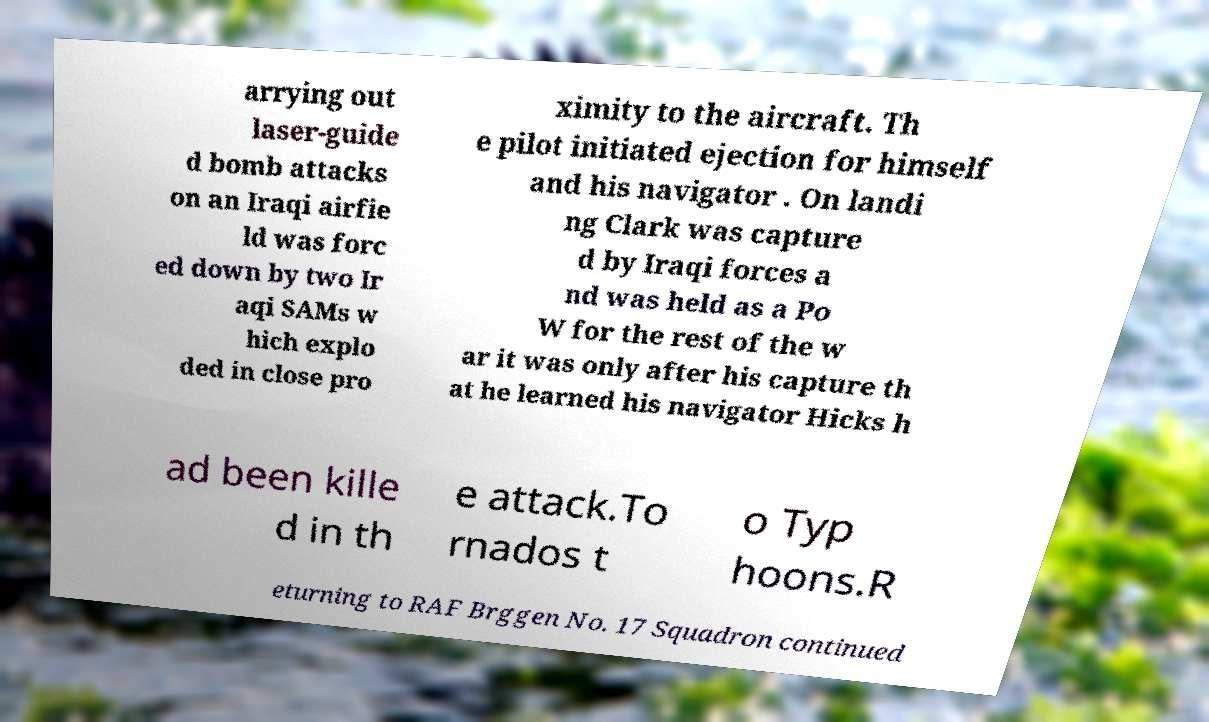Could you assist in decoding the text presented in this image and type it out clearly? arrying out laser-guide d bomb attacks on an Iraqi airfie ld was forc ed down by two Ir aqi SAMs w hich explo ded in close pro ximity to the aircraft. Th e pilot initiated ejection for himself and his navigator . On landi ng Clark was capture d by Iraqi forces a nd was held as a Po W for the rest of the w ar it was only after his capture th at he learned his navigator Hicks h ad been kille d in th e attack.To rnados t o Typ hoons.R eturning to RAF Brggen No. 17 Squadron continued 